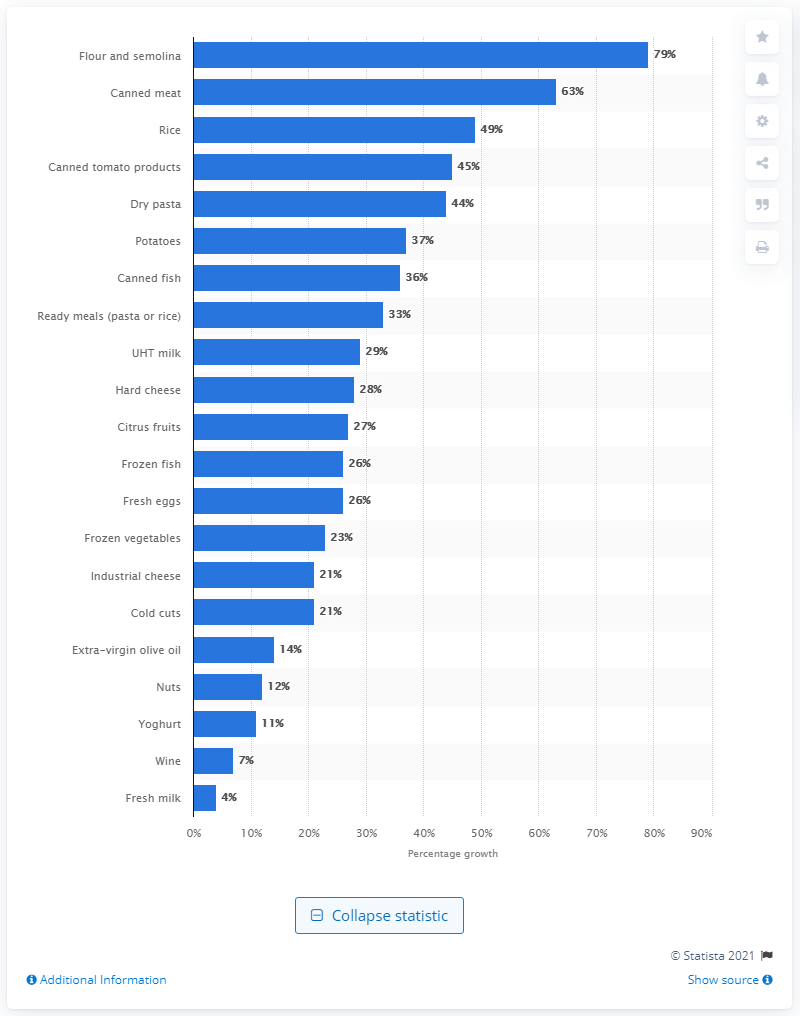Highlight a few significant elements in this photo. The sales of flour increased between mid-February and mid-March 2020 by 79%. 